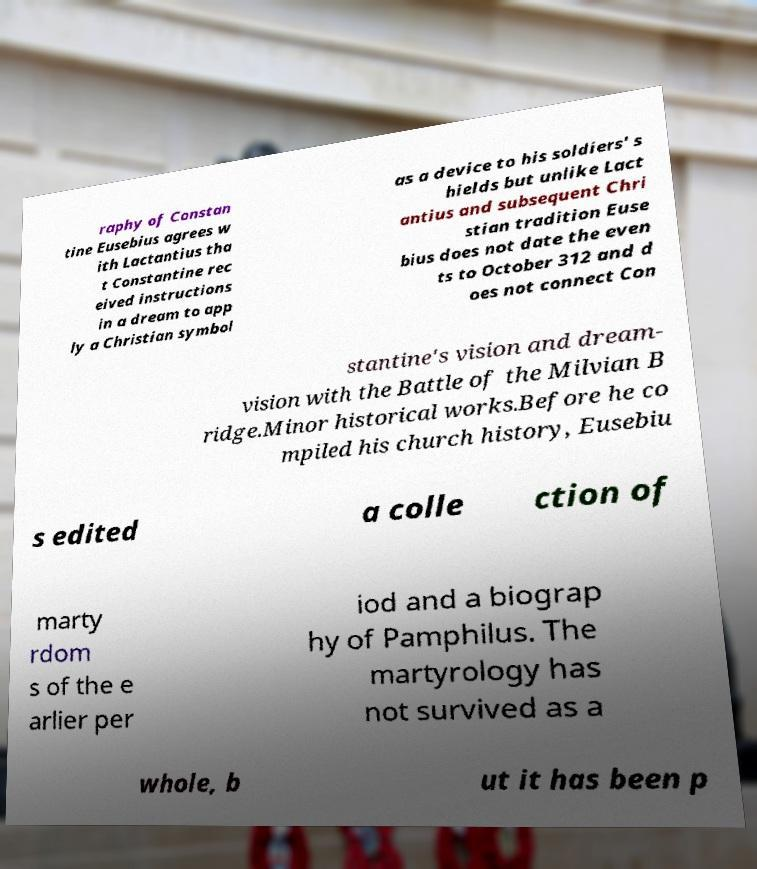What messages or text are displayed in this image? I need them in a readable, typed format. raphy of Constan tine Eusebius agrees w ith Lactantius tha t Constantine rec eived instructions in a dream to app ly a Christian symbol as a device to his soldiers' s hields but unlike Lact antius and subsequent Chri stian tradition Euse bius does not date the even ts to October 312 and d oes not connect Con stantine's vision and dream- vision with the Battle of the Milvian B ridge.Minor historical works.Before he co mpiled his church history, Eusebiu s edited a colle ction of marty rdom s of the e arlier per iod and a biograp hy of Pamphilus. The martyrology has not survived as a whole, b ut it has been p 